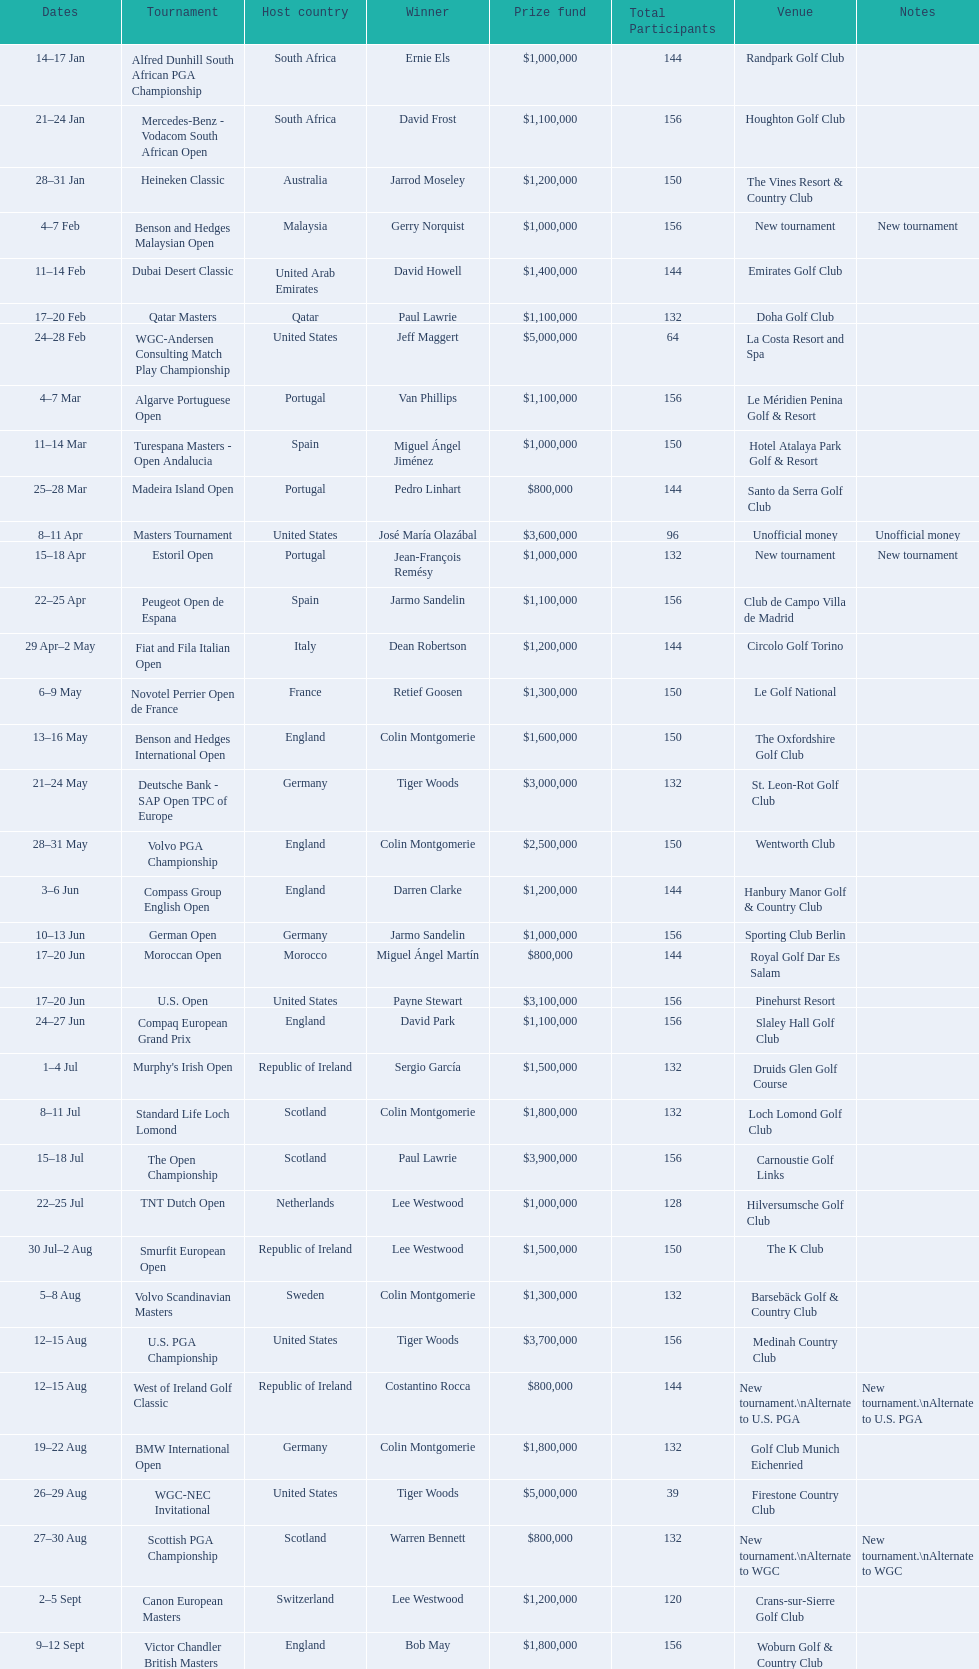What was the country listed the first time there was a new tournament? Malaysia. 